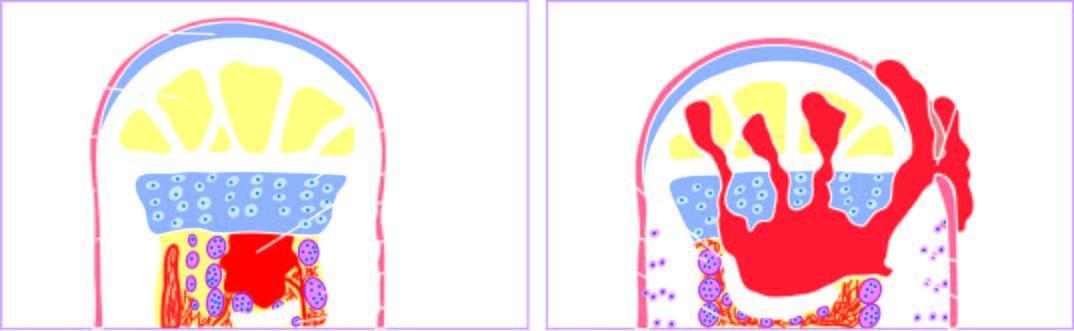what does the abscess expand?
Answer the question using a single word or phrase. Further causing necrosis of the cortex called sequestrum 